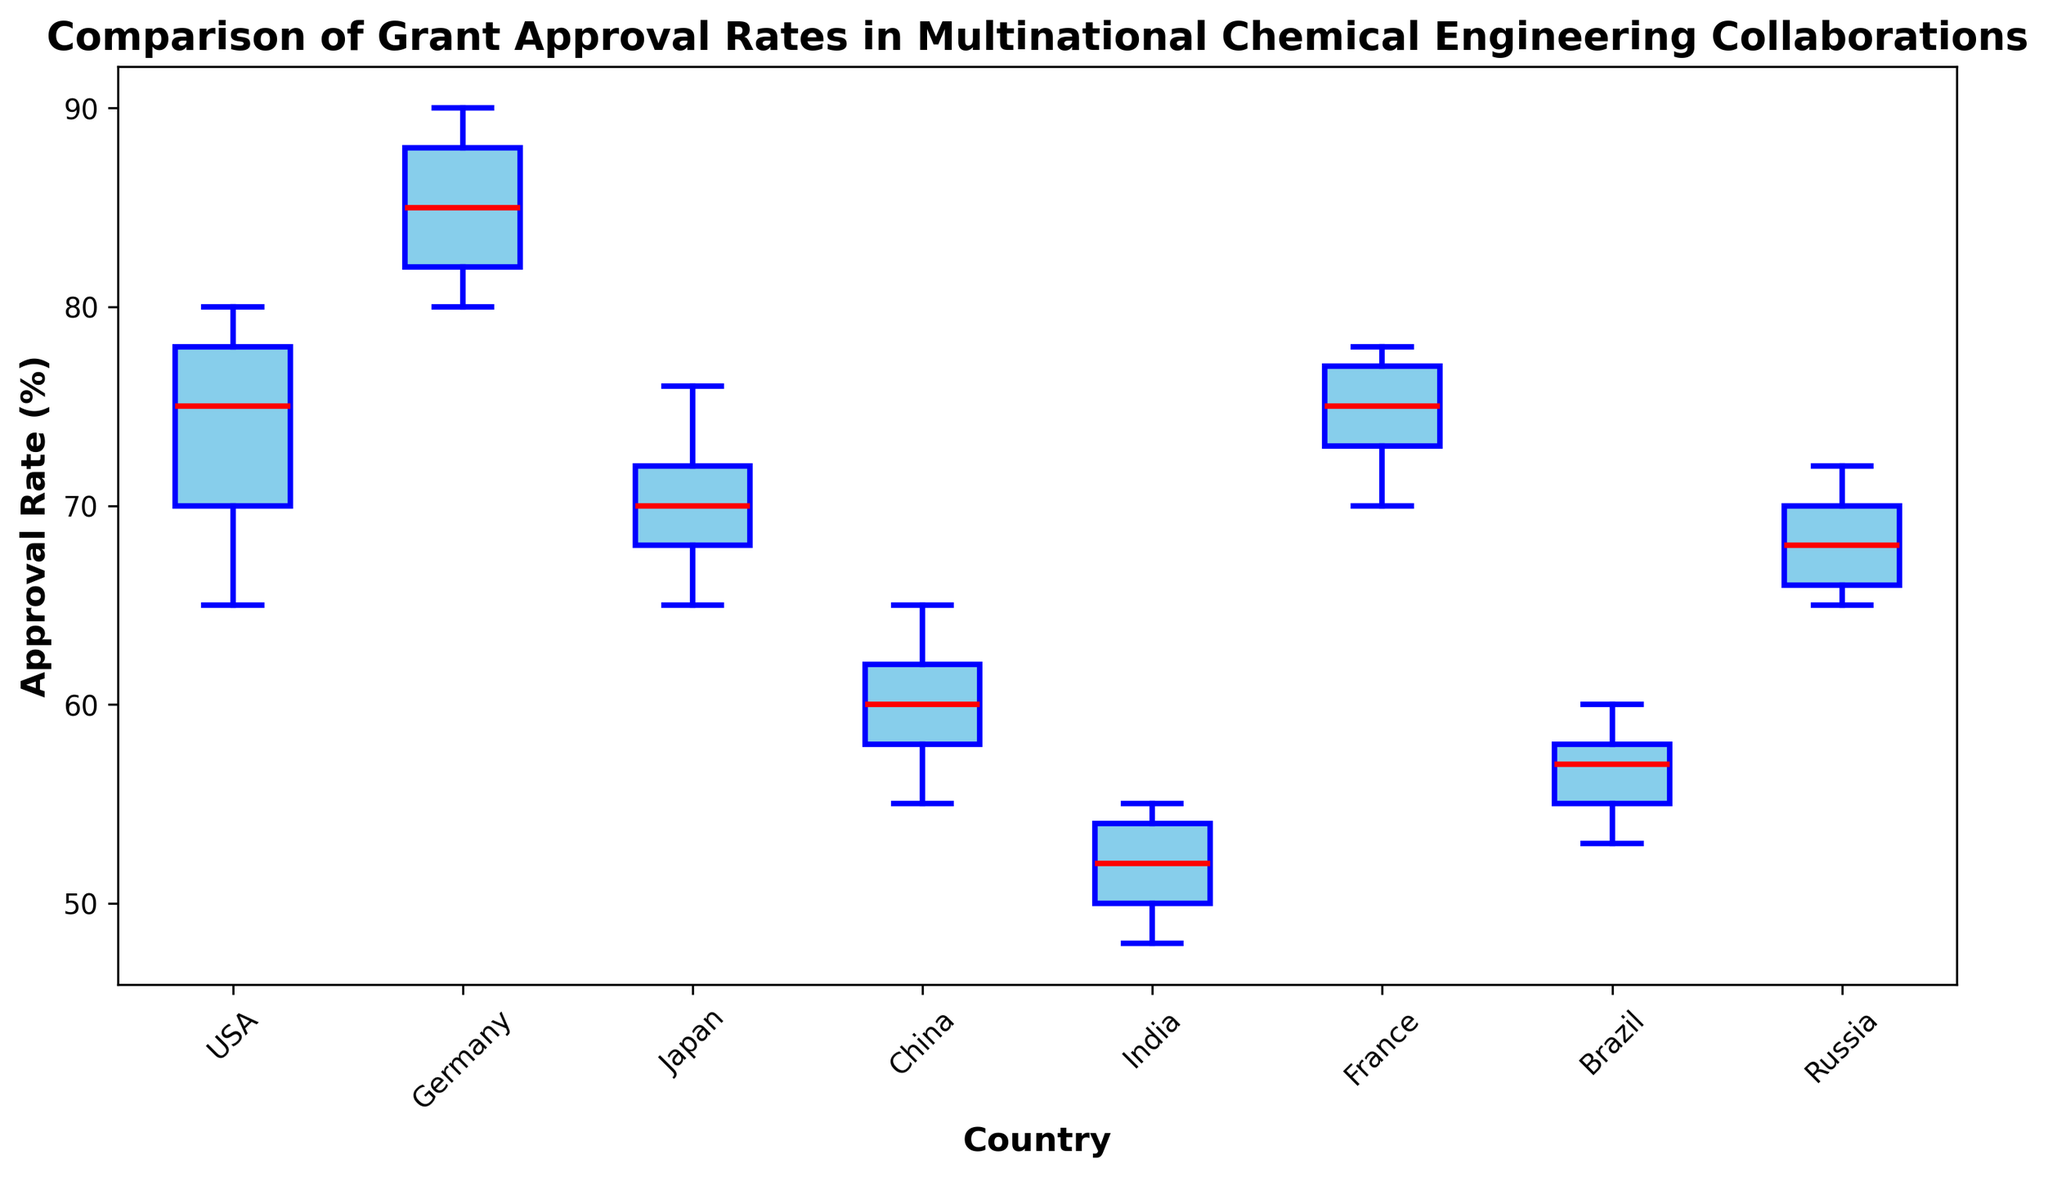What country has the highest median approval rate? By visually inspecting the red lines (which represent the median) in each box plot, we can see that Germany's box has the highest median line.
Answer: Germany Which country has the widest range in approval rates? The width of the range in approval rates can be seen by looking at the vertical span of the whiskers in each box plot. Germany has the widest range, with whiskers extending from approximately 80 to 90.
Answer: Germany Compare the median approval rates of USA and China. Which country has the higher median rate? By comparing the red median lines of USA and China, we can see that the median line for USA is higher than that for China.
Answer: USA What is the approximate interquartile range (IQR) for Japan? The IQR is the difference between the third quartile (top of the box) and the first quartile (bottom of the box). Visually estimating, the box for Japan spans from around 65 to 72. Thus, the IQR is approximately 72 - 65.
Answer: 7 Are there any countries with outliers in their approval rates? If yes, which ones? Outliers are indicated by green markers outside the whiskers in the box plot. Germany has visible outliers beyond the whiskers.
Answer: Germany 